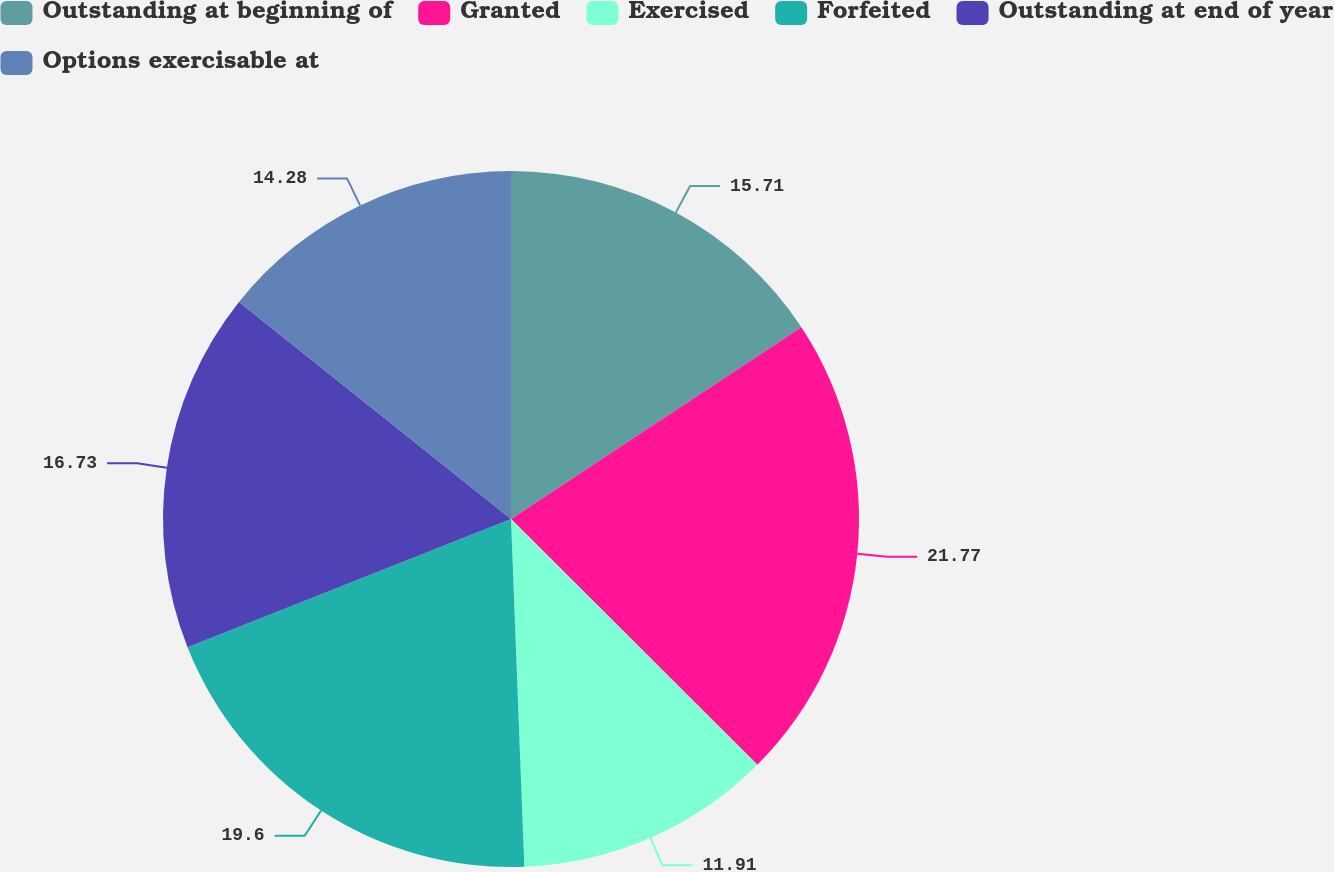Convert chart. <chart><loc_0><loc_0><loc_500><loc_500><pie_chart><fcel>Outstanding at beginning of<fcel>Granted<fcel>Exercised<fcel>Forfeited<fcel>Outstanding at end of year<fcel>Options exercisable at<nl><fcel>15.71%<fcel>21.77%<fcel>11.91%<fcel>19.6%<fcel>16.73%<fcel>14.28%<nl></chart> 